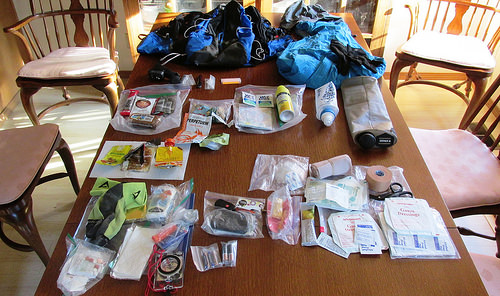<image>
Is the chair on the table? No. The chair is not positioned on the table. They may be near each other, but the chair is not supported by or resting on top of the table. 